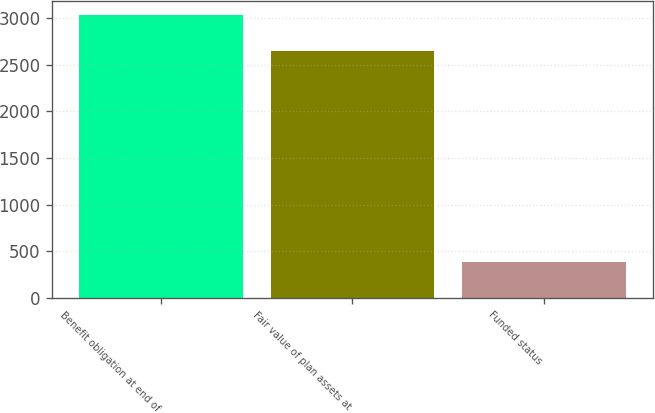Convert chart to OTSL. <chart><loc_0><loc_0><loc_500><loc_500><bar_chart><fcel>Benefit obligation at end of<fcel>Fair value of plan assets at<fcel>Funded status<nl><fcel>3035<fcel>2650<fcel>385<nl></chart> 